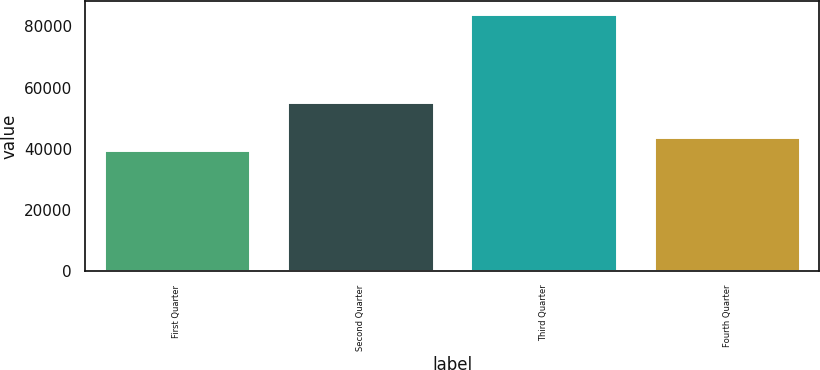Convert chart to OTSL. <chart><loc_0><loc_0><loc_500><loc_500><bar_chart><fcel>First Quarter<fcel>Second Quarter<fcel>Third Quarter<fcel>Fourth Quarter<nl><fcel>39608<fcel>55262<fcel>84035<fcel>44050.7<nl></chart> 